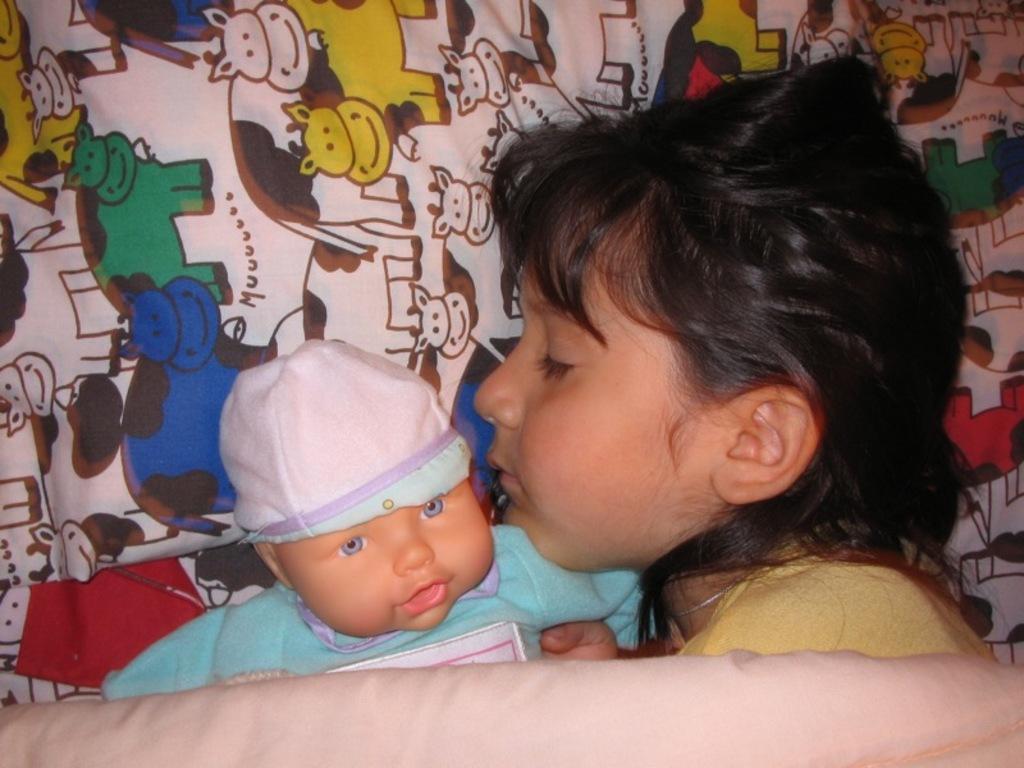Can you describe this image briefly? In this image there is a girl sleeping on the bed, beside her there is a toy baby. At the bottom of the image there is a blanket. 